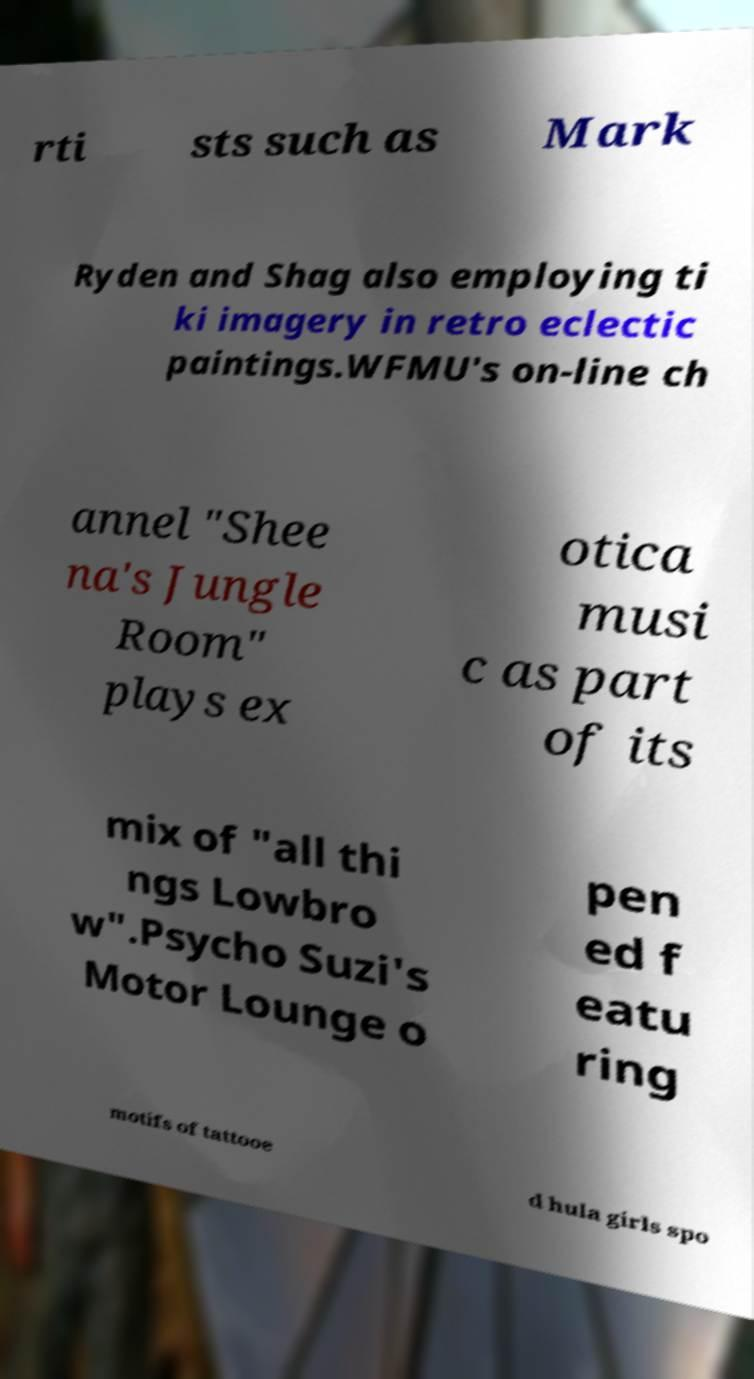For documentation purposes, I need the text within this image transcribed. Could you provide that? rti sts such as Mark Ryden and Shag also employing ti ki imagery in retro eclectic paintings.WFMU's on-line ch annel "Shee na's Jungle Room" plays ex otica musi c as part of its mix of "all thi ngs Lowbro w".Psycho Suzi's Motor Lounge o pen ed f eatu ring motifs of tattooe d hula girls spo 